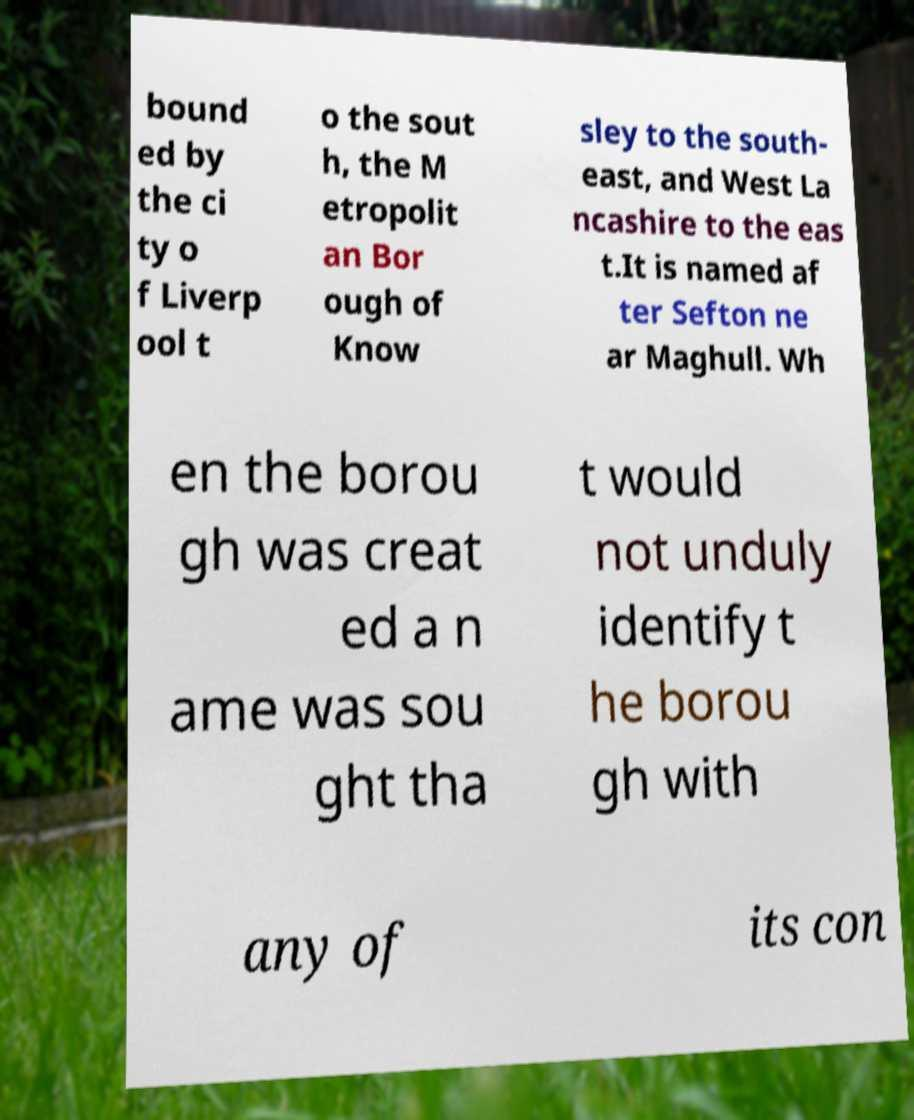Could you extract and type out the text from this image? bound ed by the ci ty o f Liverp ool t o the sout h, the M etropolit an Bor ough of Know sley to the south- east, and West La ncashire to the eas t.It is named af ter Sefton ne ar Maghull. Wh en the borou gh was creat ed a n ame was sou ght tha t would not unduly identify t he borou gh with any of its con 